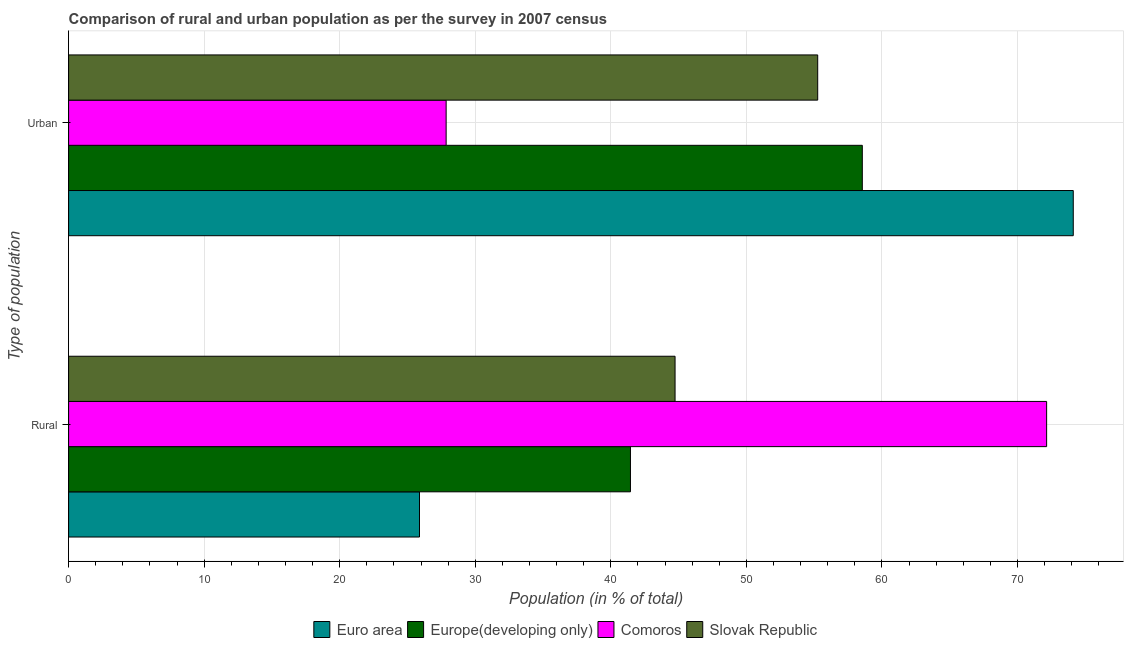How many groups of bars are there?
Provide a succinct answer. 2. Are the number of bars on each tick of the Y-axis equal?
Offer a very short reply. Yes. How many bars are there on the 1st tick from the bottom?
Keep it short and to the point. 4. What is the label of the 1st group of bars from the top?
Keep it short and to the point. Urban. What is the rural population in Slovak Republic?
Your answer should be compact. 44.74. Across all countries, what is the maximum rural population?
Provide a succinct answer. 72.15. Across all countries, what is the minimum rural population?
Provide a succinct answer. 25.89. In which country was the rural population maximum?
Your answer should be compact. Comoros. What is the total rural population in the graph?
Ensure brevity in your answer.  184.22. What is the difference between the rural population in Europe(developing only) and that in Comoros?
Give a very brief answer. -30.7. What is the difference between the rural population in Comoros and the urban population in Europe(developing only)?
Offer a very short reply. 13.6. What is the average urban population per country?
Your response must be concise. 53.94. What is the difference between the urban population and rural population in Slovak Republic?
Provide a short and direct response. 10.52. What is the ratio of the rural population in Comoros to that in Europe(developing only)?
Offer a very short reply. 1.74. What does the 4th bar from the top in Rural represents?
Give a very brief answer. Euro area. What does the 2nd bar from the bottom in Urban represents?
Your answer should be very brief. Europe(developing only). How many bars are there?
Offer a terse response. 8. Are the values on the major ticks of X-axis written in scientific E-notation?
Your answer should be compact. No. Does the graph contain any zero values?
Your answer should be compact. No. Does the graph contain grids?
Your answer should be compact. Yes. Where does the legend appear in the graph?
Offer a terse response. Bottom center. How many legend labels are there?
Provide a short and direct response. 4. What is the title of the graph?
Make the answer very short. Comparison of rural and urban population as per the survey in 2007 census. What is the label or title of the X-axis?
Ensure brevity in your answer.  Population (in % of total). What is the label or title of the Y-axis?
Offer a terse response. Type of population. What is the Population (in % of total) of Euro area in Rural?
Provide a succinct answer. 25.89. What is the Population (in % of total) in Europe(developing only) in Rural?
Offer a very short reply. 41.45. What is the Population (in % of total) of Comoros in Rural?
Make the answer very short. 72.15. What is the Population (in % of total) in Slovak Republic in Rural?
Your answer should be compact. 44.74. What is the Population (in % of total) of Euro area in Urban?
Give a very brief answer. 74.11. What is the Population (in % of total) in Europe(developing only) in Urban?
Ensure brevity in your answer.  58.55. What is the Population (in % of total) in Comoros in Urban?
Make the answer very short. 27.85. What is the Population (in % of total) of Slovak Republic in Urban?
Your answer should be very brief. 55.26. Across all Type of population, what is the maximum Population (in % of total) of Euro area?
Give a very brief answer. 74.11. Across all Type of population, what is the maximum Population (in % of total) of Europe(developing only)?
Give a very brief answer. 58.55. Across all Type of population, what is the maximum Population (in % of total) in Comoros?
Your response must be concise. 72.15. Across all Type of population, what is the maximum Population (in % of total) in Slovak Republic?
Your answer should be very brief. 55.26. Across all Type of population, what is the minimum Population (in % of total) in Euro area?
Offer a very short reply. 25.89. Across all Type of population, what is the minimum Population (in % of total) of Europe(developing only)?
Offer a terse response. 41.45. Across all Type of population, what is the minimum Population (in % of total) in Comoros?
Provide a short and direct response. 27.85. Across all Type of population, what is the minimum Population (in % of total) in Slovak Republic?
Offer a terse response. 44.74. What is the total Population (in % of total) of Euro area in the graph?
Keep it short and to the point. 100. What is the total Population (in % of total) of Comoros in the graph?
Your answer should be very brief. 100. What is the difference between the Population (in % of total) of Euro area in Rural and that in Urban?
Make the answer very short. -48.23. What is the difference between the Population (in % of total) in Europe(developing only) in Rural and that in Urban?
Offer a terse response. -17.1. What is the difference between the Population (in % of total) of Comoros in Rural and that in Urban?
Ensure brevity in your answer.  44.3. What is the difference between the Population (in % of total) of Slovak Republic in Rural and that in Urban?
Provide a short and direct response. -10.52. What is the difference between the Population (in % of total) of Euro area in Rural and the Population (in % of total) of Europe(developing only) in Urban?
Your answer should be very brief. -32.67. What is the difference between the Population (in % of total) of Euro area in Rural and the Population (in % of total) of Comoros in Urban?
Offer a terse response. -1.96. What is the difference between the Population (in % of total) in Euro area in Rural and the Population (in % of total) in Slovak Republic in Urban?
Offer a terse response. -29.37. What is the difference between the Population (in % of total) in Europe(developing only) in Rural and the Population (in % of total) in Comoros in Urban?
Provide a succinct answer. 13.6. What is the difference between the Population (in % of total) in Europe(developing only) in Rural and the Population (in % of total) in Slovak Republic in Urban?
Keep it short and to the point. -13.81. What is the difference between the Population (in % of total) in Comoros in Rural and the Population (in % of total) in Slovak Republic in Urban?
Make the answer very short. 16.89. What is the average Population (in % of total) in Europe(developing only) per Type of population?
Your answer should be compact. 50. What is the average Population (in % of total) in Comoros per Type of population?
Your response must be concise. 50. What is the difference between the Population (in % of total) in Euro area and Population (in % of total) in Europe(developing only) in Rural?
Make the answer very short. -15.56. What is the difference between the Population (in % of total) of Euro area and Population (in % of total) of Comoros in Rural?
Keep it short and to the point. -46.26. What is the difference between the Population (in % of total) in Euro area and Population (in % of total) in Slovak Republic in Rural?
Make the answer very short. -18.85. What is the difference between the Population (in % of total) in Europe(developing only) and Population (in % of total) in Comoros in Rural?
Your answer should be compact. -30.7. What is the difference between the Population (in % of total) in Europe(developing only) and Population (in % of total) in Slovak Republic in Rural?
Keep it short and to the point. -3.29. What is the difference between the Population (in % of total) of Comoros and Population (in % of total) of Slovak Republic in Rural?
Ensure brevity in your answer.  27.41. What is the difference between the Population (in % of total) in Euro area and Population (in % of total) in Europe(developing only) in Urban?
Give a very brief answer. 15.56. What is the difference between the Population (in % of total) in Euro area and Population (in % of total) in Comoros in Urban?
Ensure brevity in your answer.  46.26. What is the difference between the Population (in % of total) in Euro area and Population (in % of total) in Slovak Republic in Urban?
Your answer should be very brief. 18.85. What is the difference between the Population (in % of total) in Europe(developing only) and Population (in % of total) in Comoros in Urban?
Your answer should be compact. 30.7. What is the difference between the Population (in % of total) in Europe(developing only) and Population (in % of total) in Slovak Republic in Urban?
Your answer should be compact. 3.29. What is the difference between the Population (in % of total) in Comoros and Population (in % of total) in Slovak Republic in Urban?
Provide a succinct answer. -27.41. What is the ratio of the Population (in % of total) in Euro area in Rural to that in Urban?
Your answer should be very brief. 0.35. What is the ratio of the Population (in % of total) in Europe(developing only) in Rural to that in Urban?
Ensure brevity in your answer.  0.71. What is the ratio of the Population (in % of total) in Comoros in Rural to that in Urban?
Provide a succinct answer. 2.59. What is the ratio of the Population (in % of total) of Slovak Republic in Rural to that in Urban?
Keep it short and to the point. 0.81. What is the difference between the highest and the second highest Population (in % of total) of Euro area?
Make the answer very short. 48.23. What is the difference between the highest and the second highest Population (in % of total) of Europe(developing only)?
Provide a succinct answer. 17.1. What is the difference between the highest and the second highest Population (in % of total) in Comoros?
Your response must be concise. 44.3. What is the difference between the highest and the second highest Population (in % of total) of Slovak Republic?
Your answer should be very brief. 10.52. What is the difference between the highest and the lowest Population (in % of total) of Euro area?
Provide a succinct answer. 48.23. What is the difference between the highest and the lowest Population (in % of total) in Europe(developing only)?
Provide a succinct answer. 17.1. What is the difference between the highest and the lowest Population (in % of total) of Comoros?
Your response must be concise. 44.3. What is the difference between the highest and the lowest Population (in % of total) in Slovak Republic?
Make the answer very short. 10.52. 